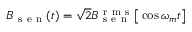<formula> <loc_0><loc_0><loc_500><loc_500>B _ { s e n } ( t ) = \sqrt { 2 } B _ { s e n } ^ { r m s } \left [ \cos \omega _ { m } t \right ]</formula> 